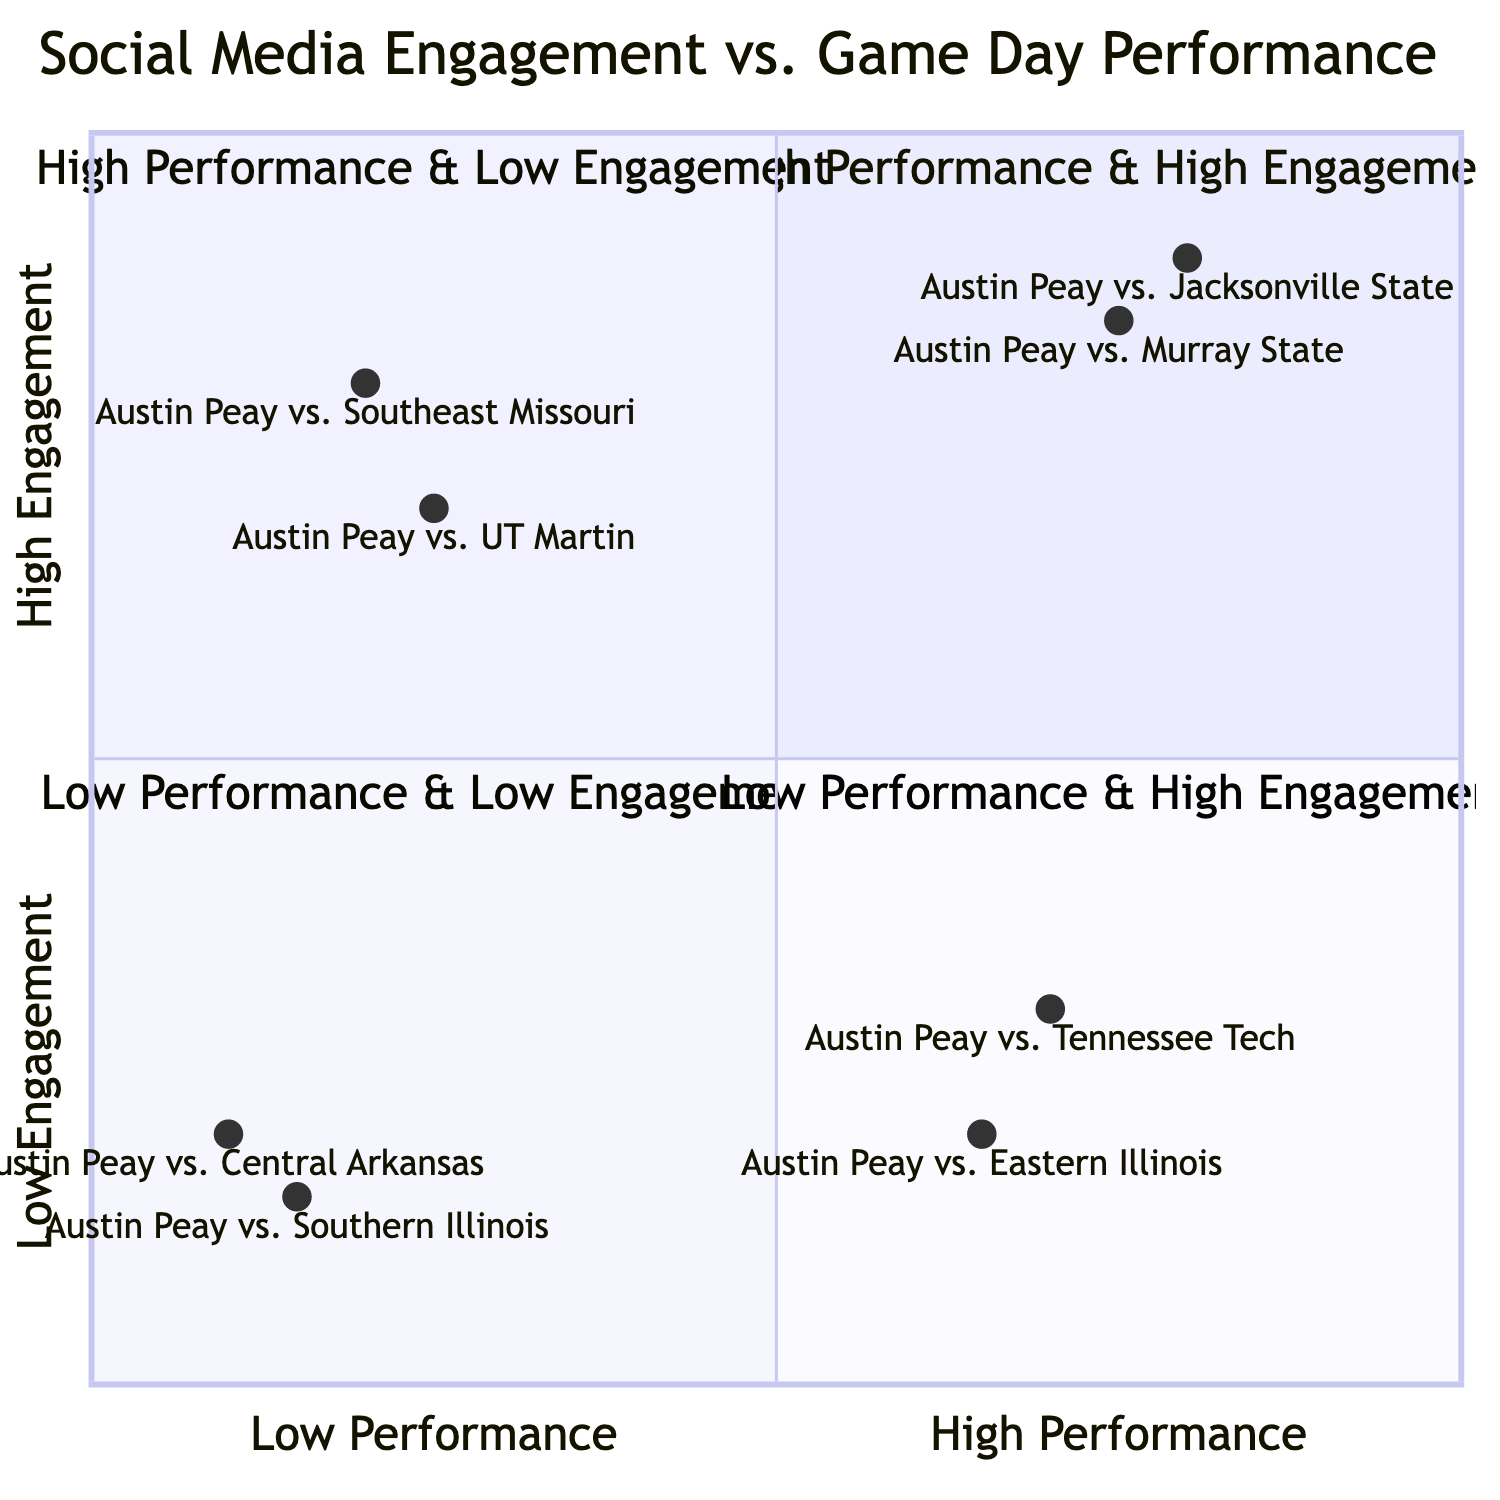What game had the highest social engagement in the high-performance quadrant? The high-performance and high-engagement quadrant includes games where Austin Peay performed well and received high levels of social media interaction. The game with the highest social engagement metric listed is "Austin Peay vs. Jacksonville State" with over 5,000 interactions.
Answer: Austin Peay vs. Jacksonville State What is the social engagement metric for the game against Central Arkansas? The game against Central Arkansas falls in the low-performance and low-engagement quadrant with a social engagement metric of under 1,000 interactions.
Answer: Under 1,000 interactions How many games fall in the low performance & high engagement quadrant? The low performance and high engagement quadrant contains two games: "Austin Peay vs. Southeast Missouri" and "Austin Peay vs. UT Martin". Therefore, there are two games in this quadrant.
Answer: 2 What is the performance metric for the game against Tennessee Tech? The performance metric for the game against Tennessee Tech is a victory, which places it in the high-performance and low engagement quadrant.
Answer: Victory Which quadrant contains games with both low performance and low engagement? The quadrant specifically detailing both low performance and low engagement is labeled as "Low Performance & Low Engagement". This includes the games "Austin Peay vs. Central Arkansas" and "Austin Peay vs. Southern Illinois".
Answer: Low Performance & Low Engagement How does the engagement for the game against UT Martin compare to the engagement for the game against Southern Illinois? The engagement for the game against UT Martin (over 3,500 interactions) is higher than that for Southern Illinois (under 800 interactions). This signifies a notable difference in social media engagement even though both games ended in defeats.
Answer: UT Martin has higher engagement What is the total number of games represented in the diagram? The diagram includes eight distinct games, with two games represented in each of the four quadrants, leading to a total count of eight games.
Answer: 8 Which game showed a victory but had under 1,500 social media interactions? In the high-performance and low engagement quadrant, the game "Austin Peay vs. Tennessee Tech" is noted for showing a victory while having under 1,500 social media interactions.
Answer: Austin Peay vs. Tennessee Tech 